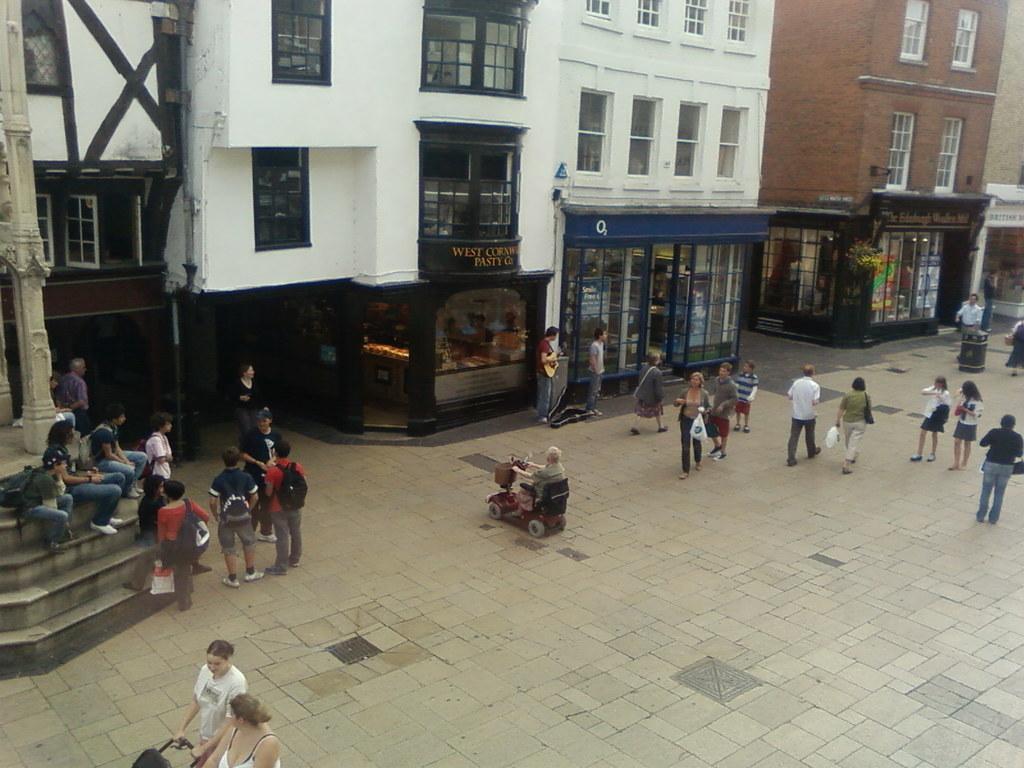Describe this image in one or two sentences. In this picture we can see buildings in the background, there are some people walking at the bottom, on the left side there are some people standing and some people sitting on stairs, we can see windows and glasses of these buildings, on the left side there is a pole, we can see a vehicle in the middle. 